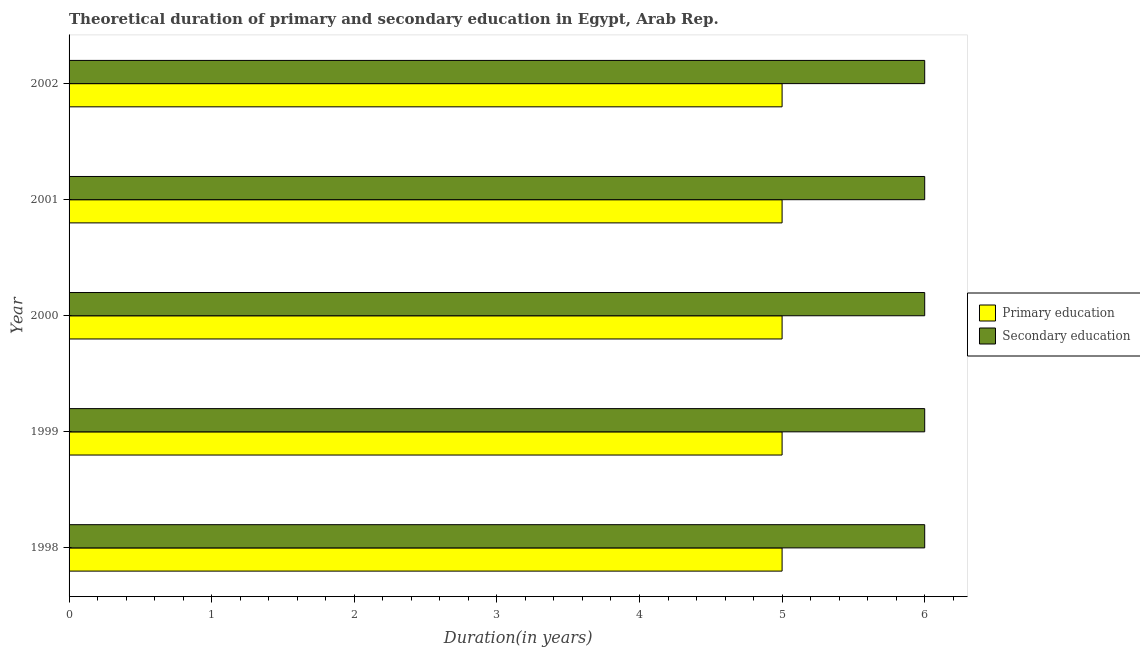How many groups of bars are there?
Offer a very short reply. 5. Are the number of bars per tick equal to the number of legend labels?
Your response must be concise. Yes. How many bars are there on the 1st tick from the top?
Make the answer very short. 2. What is the label of the 4th group of bars from the top?
Provide a succinct answer. 1999. Across all years, what is the maximum duration of primary education?
Your answer should be very brief. 5. Across all years, what is the minimum duration of primary education?
Make the answer very short. 5. What is the total duration of primary education in the graph?
Your response must be concise. 25. What is the difference between the duration of secondary education in 2000 and the duration of primary education in 1998?
Your answer should be very brief. 1. What is the average duration of primary education per year?
Give a very brief answer. 5. In the year 2000, what is the difference between the duration of primary education and duration of secondary education?
Offer a terse response. -1. What is the ratio of the duration of primary education in 1999 to that in 2000?
Ensure brevity in your answer.  1. Is the duration of secondary education in 1999 less than that in 2001?
Offer a terse response. No. Is the difference between the duration of secondary education in 1998 and 1999 greater than the difference between the duration of primary education in 1998 and 1999?
Your answer should be very brief. No. What is the difference between the highest and the second highest duration of secondary education?
Offer a very short reply. 0. In how many years, is the duration of secondary education greater than the average duration of secondary education taken over all years?
Your answer should be very brief. 0. Is the sum of the duration of secondary education in 1998 and 2001 greater than the maximum duration of primary education across all years?
Your answer should be very brief. Yes. What does the 2nd bar from the bottom in 2002 represents?
Provide a succinct answer. Secondary education. Are all the bars in the graph horizontal?
Keep it short and to the point. Yes. How many years are there in the graph?
Ensure brevity in your answer.  5. Are the values on the major ticks of X-axis written in scientific E-notation?
Make the answer very short. No. Does the graph contain any zero values?
Provide a succinct answer. No. Where does the legend appear in the graph?
Your answer should be very brief. Center right. How many legend labels are there?
Make the answer very short. 2. What is the title of the graph?
Your answer should be very brief. Theoretical duration of primary and secondary education in Egypt, Arab Rep. What is the label or title of the X-axis?
Give a very brief answer. Duration(in years). What is the Duration(in years) of Secondary education in 1998?
Give a very brief answer. 6. What is the Duration(in years) of Primary education in 2000?
Make the answer very short. 5. What is the Duration(in years) in Primary education in 2001?
Provide a succinct answer. 5. What is the Duration(in years) of Secondary education in 2001?
Provide a succinct answer. 6. What is the Duration(in years) in Primary education in 2002?
Make the answer very short. 5. What is the total Duration(in years) of Secondary education in the graph?
Your response must be concise. 30. What is the difference between the Duration(in years) in Secondary education in 1998 and that in 1999?
Ensure brevity in your answer.  0. What is the difference between the Duration(in years) in Primary education in 1998 and that in 2000?
Give a very brief answer. 0. What is the difference between the Duration(in years) in Secondary education in 1998 and that in 2000?
Ensure brevity in your answer.  0. What is the difference between the Duration(in years) in Primary education in 1998 and that in 2001?
Offer a terse response. 0. What is the difference between the Duration(in years) of Secondary education in 1998 and that in 2001?
Give a very brief answer. 0. What is the difference between the Duration(in years) in Secondary education in 1998 and that in 2002?
Your response must be concise. 0. What is the difference between the Duration(in years) in Primary education in 1999 and that in 2000?
Provide a short and direct response. 0. What is the difference between the Duration(in years) in Primary education in 1999 and that in 2002?
Provide a short and direct response. 0. What is the difference between the Duration(in years) of Secondary education in 1999 and that in 2002?
Your answer should be very brief. 0. What is the difference between the Duration(in years) of Primary education in 2000 and that in 2001?
Your answer should be compact. 0. What is the difference between the Duration(in years) of Primary education in 2000 and that in 2002?
Your response must be concise. 0. What is the difference between the Duration(in years) of Secondary education in 2001 and that in 2002?
Keep it short and to the point. 0. What is the difference between the Duration(in years) in Primary education in 1998 and the Duration(in years) in Secondary education in 2000?
Offer a terse response. -1. What is the difference between the Duration(in years) in Primary education in 1999 and the Duration(in years) in Secondary education in 2001?
Keep it short and to the point. -1. What is the difference between the Duration(in years) in Primary education in 1999 and the Duration(in years) in Secondary education in 2002?
Give a very brief answer. -1. What is the difference between the Duration(in years) of Primary education in 2000 and the Duration(in years) of Secondary education in 2001?
Provide a short and direct response. -1. What is the difference between the Duration(in years) in Primary education in 2001 and the Duration(in years) in Secondary education in 2002?
Ensure brevity in your answer.  -1. What is the average Duration(in years) of Secondary education per year?
Offer a very short reply. 6. In the year 1999, what is the difference between the Duration(in years) in Primary education and Duration(in years) in Secondary education?
Provide a succinct answer. -1. In the year 2000, what is the difference between the Duration(in years) in Primary education and Duration(in years) in Secondary education?
Provide a succinct answer. -1. What is the ratio of the Duration(in years) of Secondary education in 1998 to that in 1999?
Ensure brevity in your answer.  1. What is the ratio of the Duration(in years) of Secondary education in 1998 to that in 2001?
Your response must be concise. 1. What is the ratio of the Duration(in years) in Primary education in 1999 to that in 2000?
Ensure brevity in your answer.  1. What is the ratio of the Duration(in years) of Secondary education in 1999 to that in 2000?
Provide a succinct answer. 1. What is the ratio of the Duration(in years) in Secondary education in 1999 to that in 2001?
Your answer should be very brief. 1. What is the ratio of the Duration(in years) of Primary education in 1999 to that in 2002?
Provide a short and direct response. 1. What is the ratio of the Duration(in years) in Secondary education in 1999 to that in 2002?
Your answer should be compact. 1. What is the ratio of the Duration(in years) in Primary education in 2000 to that in 2001?
Your response must be concise. 1. What is the ratio of the Duration(in years) of Secondary education in 2000 to that in 2001?
Your answer should be compact. 1. What is the ratio of the Duration(in years) of Primary education in 2000 to that in 2002?
Your answer should be compact. 1. What is the ratio of the Duration(in years) in Primary education in 2001 to that in 2002?
Keep it short and to the point. 1. What is the ratio of the Duration(in years) in Secondary education in 2001 to that in 2002?
Ensure brevity in your answer.  1. What is the difference between the highest and the second highest Duration(in years) in Secondary education?
Your answer should be very brief. 0. 